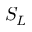<formula> <loc_0><loc_0><loc_500><loc_500>S _ { L }</formula> 